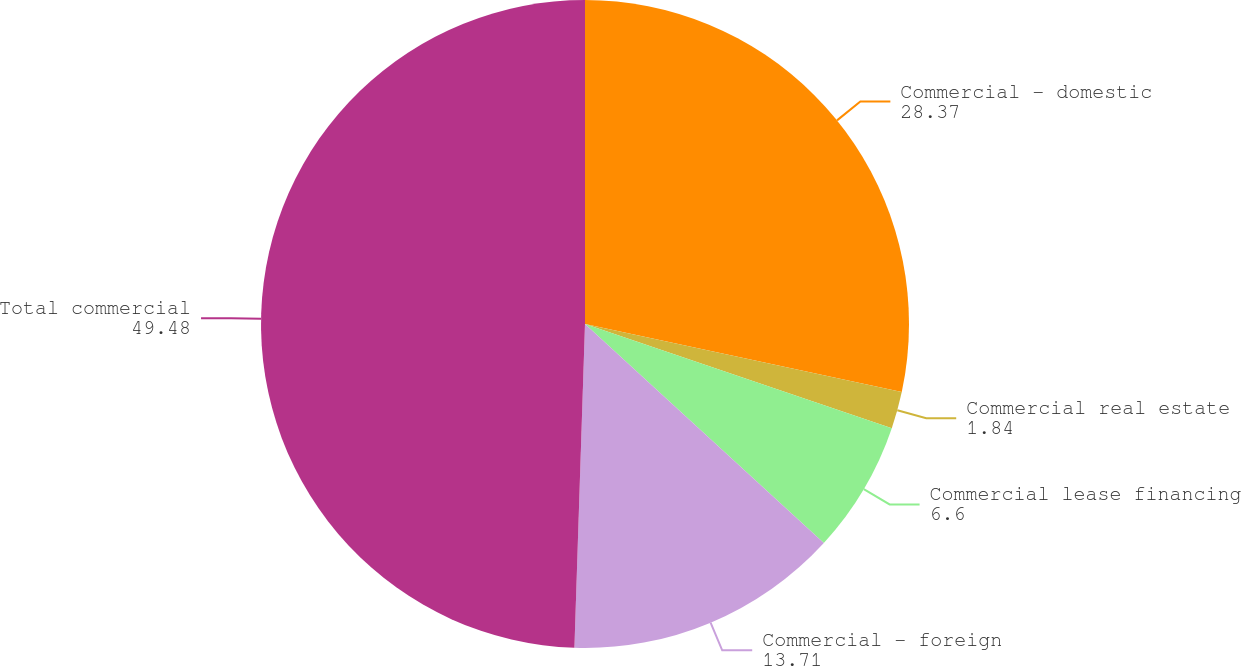Convert chart. <chart><loc_0><loc_0><loc_500><loc_500><pie_chart><fcel>Commercial - domestic<fcel>Commercial real estate<fcel>Commercial lease financing<fcel>Commercial - foreign<fcel>Total commercial<nl><fcel>28.37%<fcel>1.84%<fcel>6.6%<fcel>13.71%<fcel>49.48%<nl></chart> 